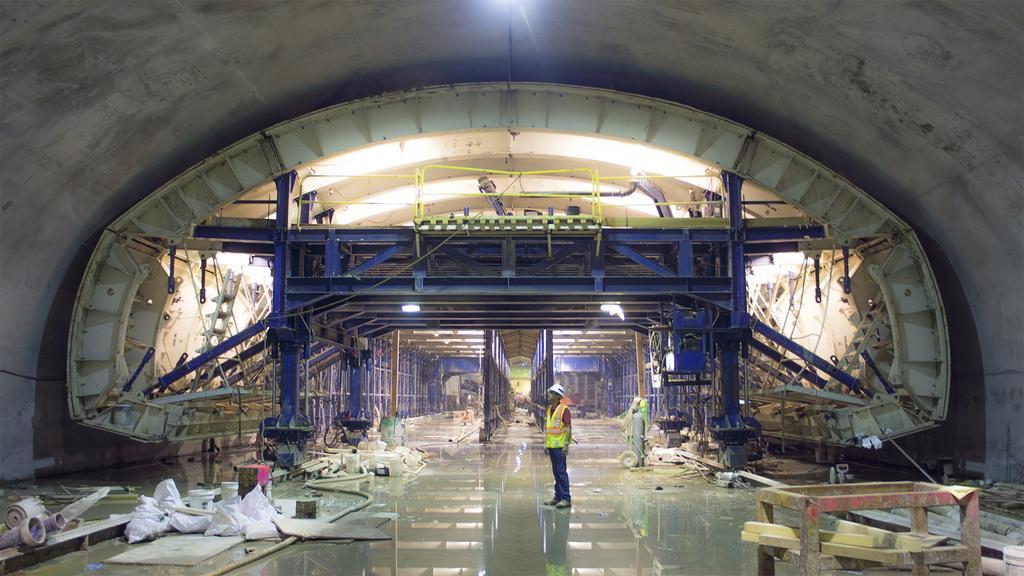Describe this image in one or two sentences. In this picture we can see a tunnel, there are two lights and a person in the middle, this person is standing, on the left side there are pipes and bags, in the background we can see some metal rods. 